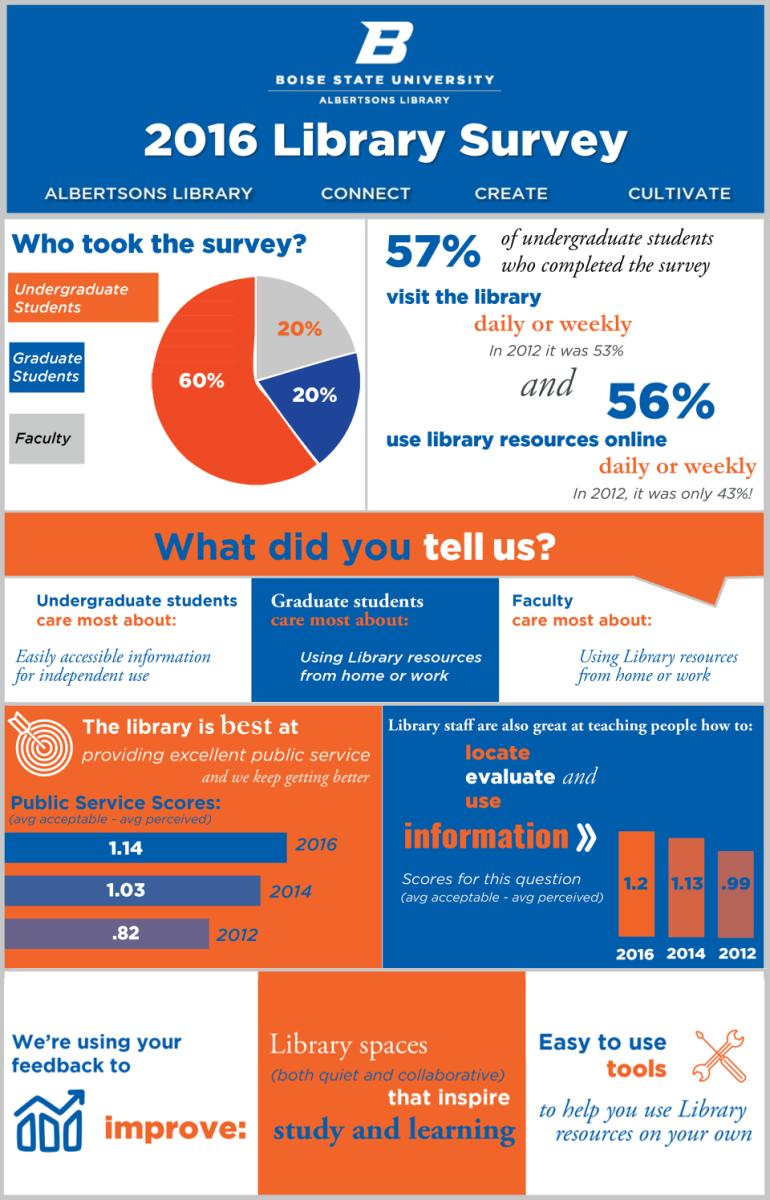Mention a couple of crucial points in this snapshot. According to the 2016 library survey, approximately 20% of the faculty members at Boise State University are represented. According to the 2016 library survey, approximately 60% of Boise State University's undergraduate students were represented. According to the 2016 library survey, approximately 20% of Boise State University's graduate students were reported. 